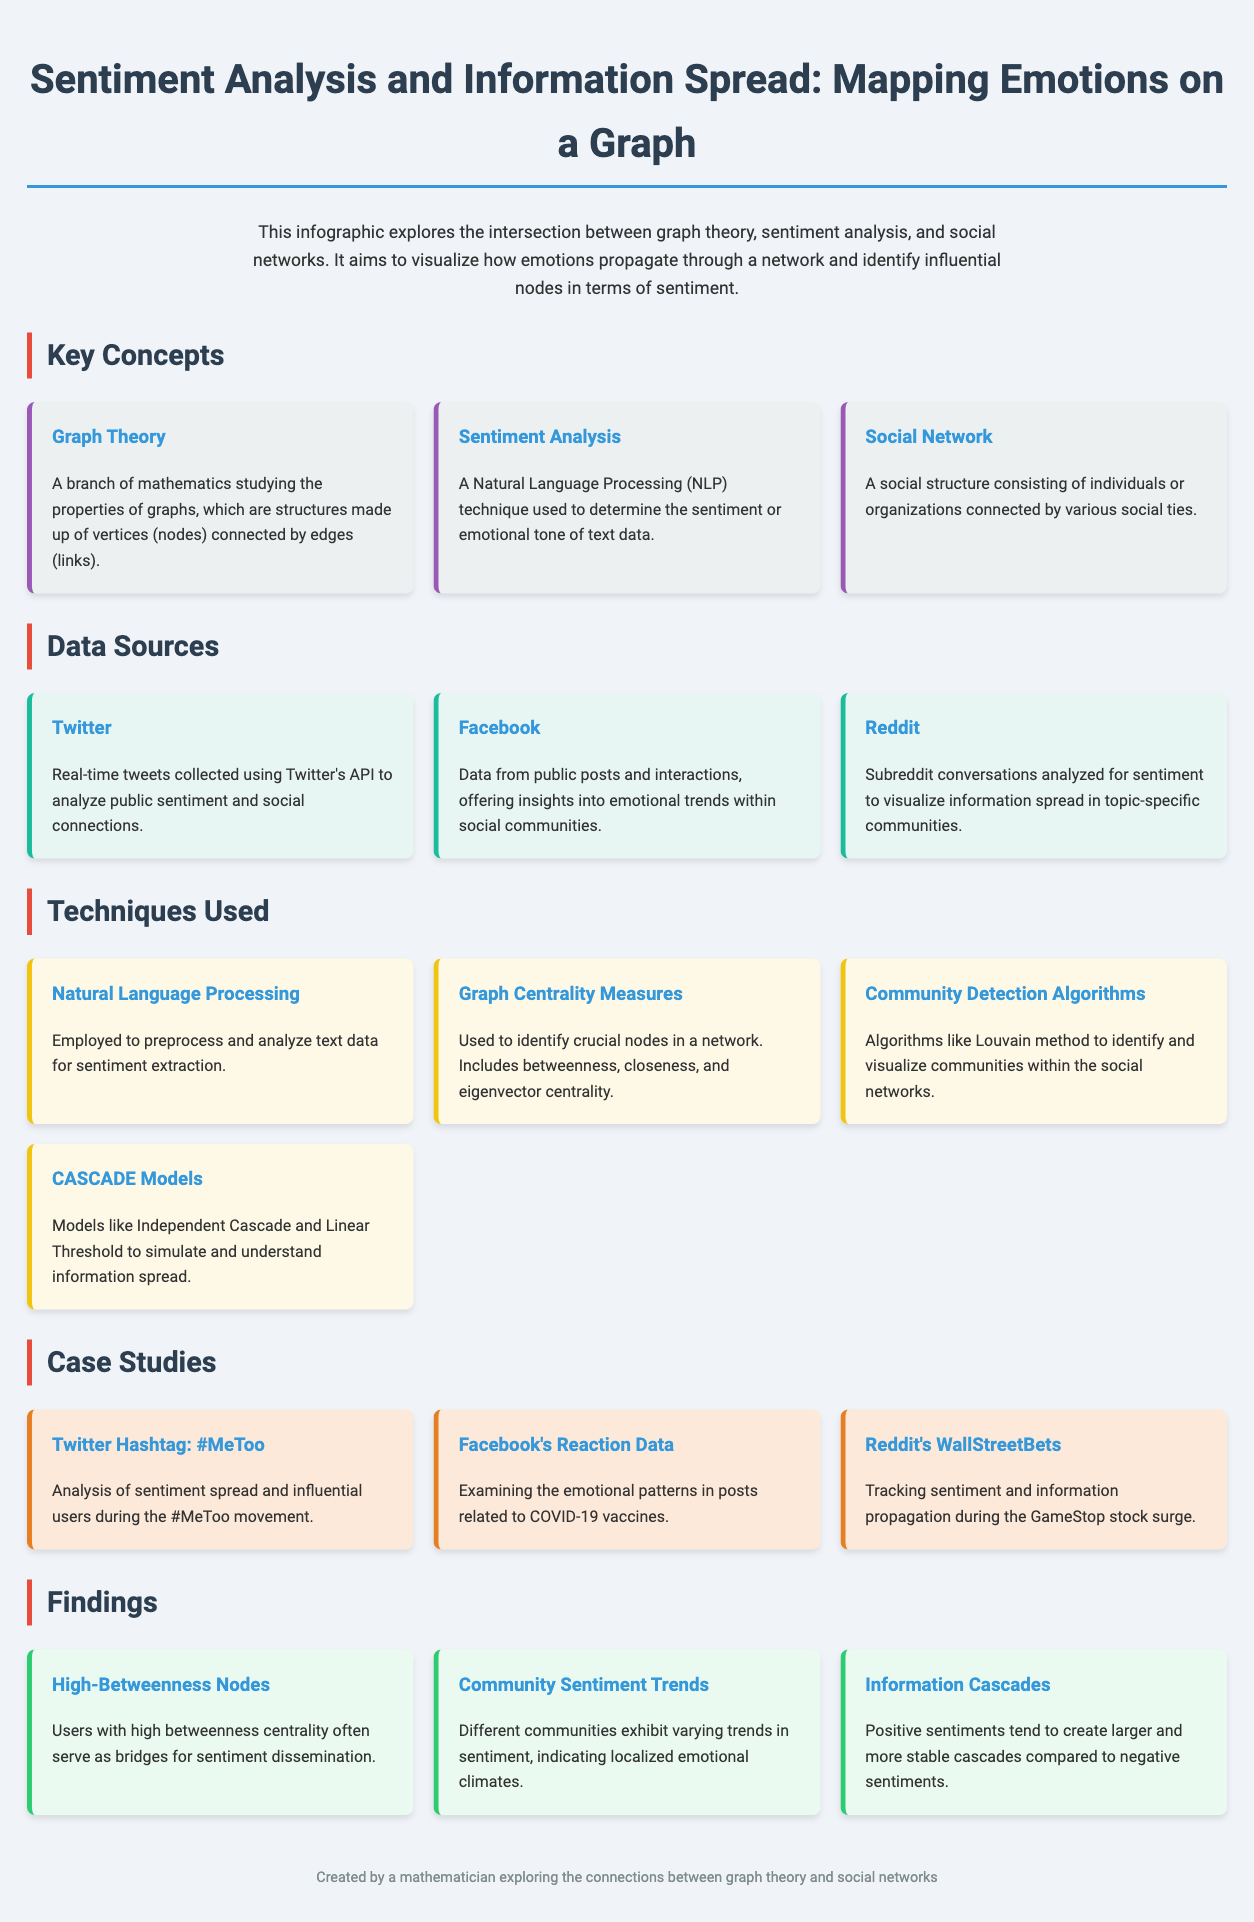What is the main topic of the infographic? The infographic explores the intersection between graph theory, sentiment analysis, and social networks, mapping how emotions propagate through a network.
Answer: Sentiment Analysis and Information Spread Which social media platform is used for real-time tweets? The data source mentions using Twitter's API to collect real-time tweets for analysis.
Answer: Twitter What emotional trend is examined in Facebook data? The infographic discusses examining emotional patterns in posts related to COVID-19 vaccines.
Answer: COVID-19 vaccines What technique is used to identify crucial nodes in a network? The document specifically refers to graph centrality measures as a technique for identifying crucial nodes, including betweenness, closeness, and eigenvector centrality.
Answer: Graph Centrality Measures In the case study, which hashtag represents a movement for social awareness? The case study featured the analysis of sentiment spread and influential users during the #MeToo movement.
Answer: #MeToo According to the findings, what do high-betweenness nodes serve as in sentiment dissemination? The finding states that users with high betweenness centrality often serve as bridges for sentiment dissemination.
Answer: Bridges What algorithm is mentioned for community detection within social networks? The infographic mentions the use of the Louvain method as an algorithm for community detection within social networks.
Answer: Louvain method What sentiment tends to create larger and more stable information cascades? The findings indicate that positive sentiments create larger and more stable cascades compared to negative sentiments.
Answer: Positive sentiments 